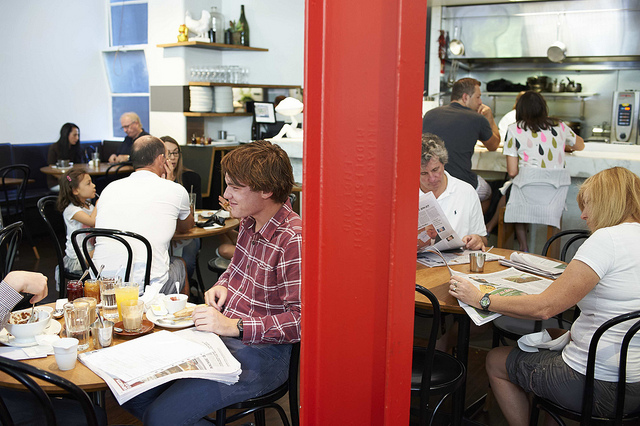How many people are there? I can see several guests seated at various tables, suggesting a busy atmosphere typically found in a café or a casual restaurant. A precise count isn't possible due to the image angle and some potential obstructions. 